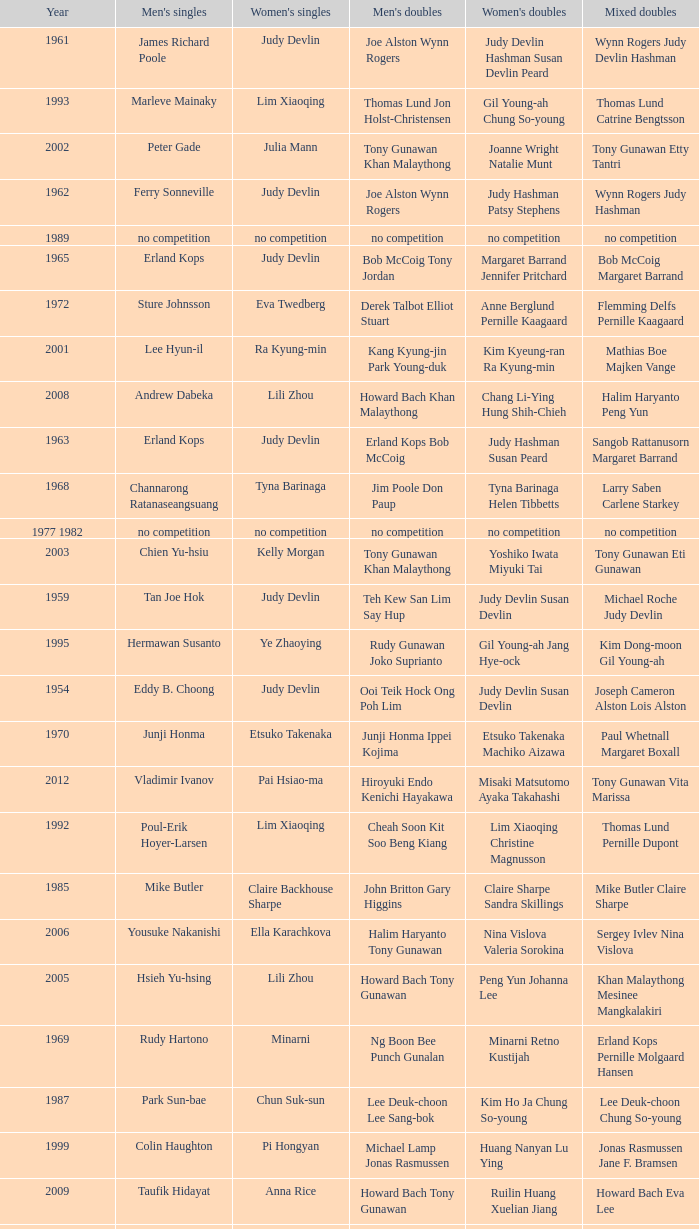Who were the men's doubles champions when the men's singles champion was muljadi? Ng Boon Bee Punch Gunalan. 